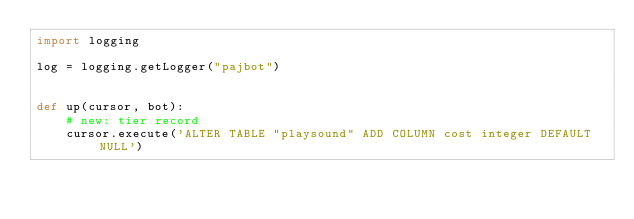Convert code to text. <code><loc_0><loc_0><loc_500><loc_500><_Python_>import logging

log = logging.getLogger("pajbot")


def up(cursor, bot):
    # new: tier record
    cursor.execute('ALTER TABLE "playsound" ADD COLUMN cost integer DEFAULT NULL')
</code> 